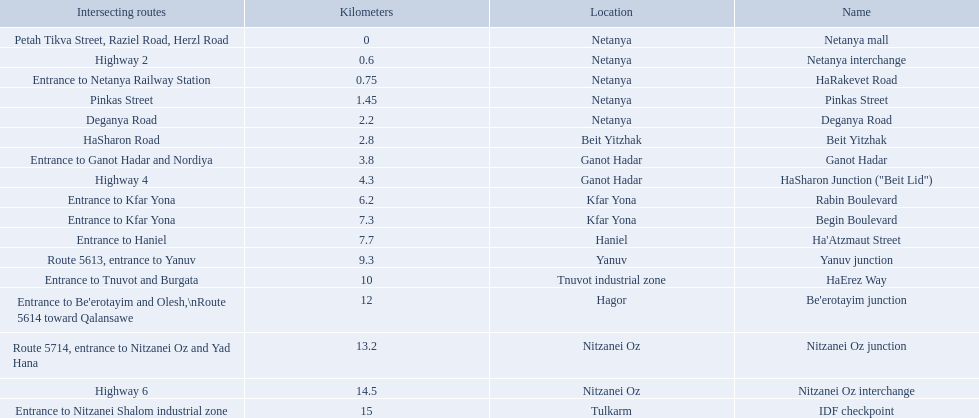Could you parse the entire table as a dict? {'header': ['Intersecting routes', 'Kilometers', 'Location', 'Name'], 'rows': [['Petah Tikva Street, Raziel Road, Herzl Road', '0', 'Netanya', 'Netanya mall'], ['Highway 2', '0.6', 'Netanya', 'Netanya interchange'], ['Entrance to Netanya Railway Station', '0.75', 'Netanya', 'HaRakevet Road'], ['Pinkas Street', '1.45', 'Netanya', 'Pinkas Street'], ['Deganya Road', '2.2', 'Netanya', 'Deganya Road'], ['HaSharon Road', '2.8', 'Beit Yitzhak', 'Beit Yitzhak'], ['Entrance to Ganot Hadar and Nordiya', '3.8', 'Ganot Hadar', 'Ganot Hadar'], ['Highway 4', '4.3', 'Ganot Hadar', 'HaSharon Junction ("Beit Lid")'], ['Entrance to Kfar Yona', '6.2', 'Kfar Yona', 'Rabin Boulevard'], ['Entrance to Kfar Yona', '7.3', 'Kfar Yona', 'Begin Boulevard'], ['Entrance to Haniel', '7.7', 'Haniel', "Ha'Atzmaut Street"], ['Route 5613, entrance to Yanuv', '9.3', 'Yanuv', 'Yanuv junction'], ['Entrance to Tnuvot and Burgata', '10', 'Tnuvot industrial zone', 'HaErez Way'], ["Entrance to Be'erotayim and Olesh,\\nRoute 5614 toward Qalansawe", '12', 'Hagor', "Be'erotayim junction"], ['Route 5714, entrance to Nitzanei Oz and Yad Hana', '13.2', 'Nitzanei Oz', 'Nitzanei Oz junction'], ['Highway 6', '14.5', 'Nitzanei Oz', 'Nitzanei Oz interchange'], ['Entrance to Nitzanei Shalom industrial zone', '15', 'Tulkarm', 'IDF checkpoint']]} What are all of the different portions? Netanya mall, Netanya interchange, HaRakevet Road, Pinkas Street, Deganya Road, Beit Yitzhak, Ganot Hadar, HaSharon Junction ("Beit Lid"), Rabin Boulevard, Begin Boulevard, Ha'Atzmaut Street, Yanuv junction, HaErez Way, Be'erotayim junction, Nitzanei Oz junction, Nitzanei Oz interchange, IDF checkpoint. What is the intersecting route for rabin boulevard? Entrance to Kfar Yona. What portion also has an intersecting route of entrance to kfar yona? Begin Boulevard. 